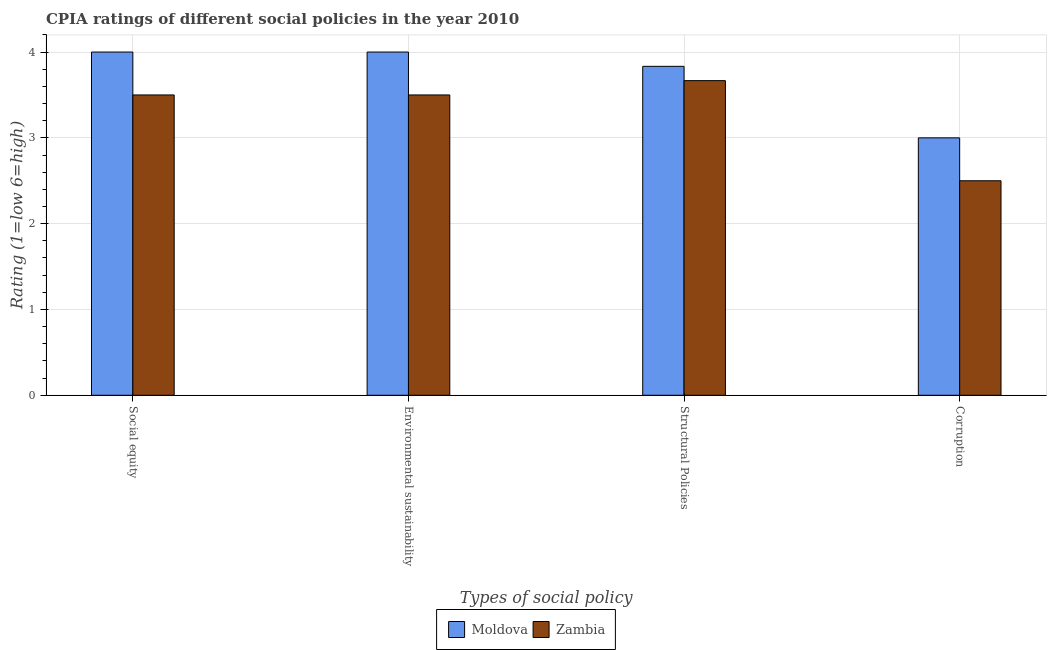How many different coloured bars are there?
Provide a succinct answer. 2. Are the number of bars per tick equal to the number of legend labels?
Give a very brief answer. Yes. Are the number of bars on each tick of the X-axis equal?
Your response must be concise. Yes. How many bars are there on the 1st tick from the right?
Make the answer very short. 2. What is the label of the 2nd group of bars from the left?
Offer a terse response. Environmental sustainability. What is the cpia rating of social equity in Moldova?
Your response must be concise. 4. Across all countries, what is the maximum cpia rating of structural policies?
Provide a succinct answer. 3.83. Across all countries, what is the minimum cpia rating of structural policies?
Offer a terse response. 3.67. In which country was the cpia rating of structural policies maximum?
Make the answer very short. Moldova. In which country was the cpia rating of social equity minimum?
Offer a terse response. Zambia. What is the difference between the cpia rating of structural policies in Zambia and the cpia rating of social equity in Moldova?
Keep it short and to the point. -0.33. What is the average cpia rating of corruption per country?
Offer a very short reply. 2.75. Is the cpia rating of environmental sustainability in Moldova less than that in Zambia?
Provide a short and direct response. No. Is the difference between the cpia rating of social equity in Zambia and Moldova greater than the difference between the cpia rating of corruption in Zambia and Moldova?
Make the answer very short. No. What is the difference between the highest and the second highest cpia rating of environmental sustainability?
Make the answer very short. 0.5. What is the difference between the highest and the lowest cpia rating of structural policies?
Provide a short and direct response. 0.17. Is the sum of the cpia rating of social equity in Moldova and Zambia greater than the maximum cpia rating of structural policies across all countries?
Your response must be concise. Yes. Is it the case that in every country, the sum of the cpia rating of structural policies and cpia rating of environmental sustainability is greater than the sum of cpia rating of social equity and cpia rating of corruption?
Offer a very short reply. Yes. What does the 2nd bar from the left in Social equity represents?
Make the answer very short. Zambia. What does the 1st bar from the right in Environmental sustainability represents?
Your answer should be compact. Zambia. Is it the case that in every country, the sum of the cpia rating of social equity and cpia rating of environmental sustainability is greater than the cpia rating of structural policies?
Your answer should be compact. Yes. How many bars are there?
Keep it short and to the point. 8. Are the values on the major ticks of Y-axis written in scientific E-notation?
Make the answer very short. No. Does the graph contain grids?
Offer a very short reply. Yes. How are the legend labels stacked?
Your response must be concise. Horizontal. What is the title of the graph?
Offer a terse response. CPIA ratings of different social policies in the year 2010. What is the label or title of the X-axis?
Your response must be concise. Types of social policy. What is the Rating (1=low 6=high) of Moldova in Social equity?
Your answer should be very brief. 4. What is the Rating (1=low 6=high) of Zambia in Environmental sustainability?
Offer a terse response. 3.5. What is the Rating (1=low 6=high) in Moldova in Structural Policies?
Your response must be concise. 3.83. What is the Rating (1=low 6=high) in Zambia in Structural Policies?
Ensure brevity in your answer.  3.67. Across all Types of social policy, what is the maximum Rating (1=low 6=high) of Moldova?
Provide a short and direct response. 4. Across all Types of social policy, what is the maximum Rating (1=low 6=high) in Zambia?
Make the answer very short. 3.67. Across all Types of social policy, what is the minimum Rating (1=low 6=high) in Zambia?
Provide a succinct answer. 2.5. What is the total Rating (1=low 6=high) in Moldova in the graph?
Offer a terse response. 14.83. What is the total Rating (1=low 6=high) in Zambia in the graph?
Keep it short and to the point. 13.17. What is the difference between the Rating (1=low 6=high) in Zambia in Social equity and that in Environmental sustainability?
Your answer should be very brief. 0. What is the difference between the Rating (1=low 6=high) in Moldova in Social equity and that in Structural Policies?
Keep it short and to the point. 0.17. What is the difference between the Rating (1=low 6=high) of Moldova in Social equity and that in Corruption?
Your answer should be compact. 1. What is the difference between the Rating (1=low 6=high) of Moldova in Environmental sustainability and that in Corruption?
Your response must be concise. 1. What is the difference between the Rating (1=low 6=high) in Zambia in Environmental sustainability and that in Corruption?
Offer a terse response. 1. What is the difference between the Rating (1=low 6=high) in Moldova in Structural Policies and that in Corruption?
Your answer should be compact. 0.83. What is the difference between the Rating (1=low 6=high) in Moldova in Social equity and the Rating (1=low 6=high) in Zambia in Environmental sustainability?
Provide a short and direct response. 0.5. What is the difference between the Rating (1=low 6=high) of Moldova in Social equity and the Rating (1=low 6=high) of Zambia in Structural Policies?
Offer a terse response. 0.33. What is the difference between the Rating (1=low 6=high) of Moldova in Social equity and the Rating (1=low 6=high) of Zambia in Corruption?
Offer a terse response. 1.5. What is the difference between the Rating (1=low 6=high) of Moldova in Environmental sustainability and the Rating (1=low 6=high) of Zambia in Structural Policies?
Make the answer very short. 0.33. What is the difference between the Rating (1=low 6=high) of Moldova in Structural Policies and the Rating (1=low 6=high) of Zambia in Corruption?
Make the answer very short. 1.33. What is the average Rating (1=low 6=high) in Moldova per Types of social policy?
Your response must be concise. 3.71. What is the average Rating (1=low 6=high) in Zambia per Types of social policy?
Provide a succinct answer. 3.29. What is the difference between the Rating (1=low 6=high) in Moldova and Rating (1=low 6=high) in Zambia in Social equity?
Offer a terse response. 0.5. What is the difference between the Rating (1=low 6=high) in Moldova and Rating (1=low 6=high) in Zambia in Environmental sustainability?
Make the answer very short. 0.5. What is the difference between the Rating (1=low 6=high) in Moldova and Rating (1=low 6=high) in Zambia in Corruption?
Offer a very short reply. 0.5. What is the ratio of the Rating (1=low 6=high) of Moldova in Social equity to that in Structural Policies?
Make the answer very short. 1.04. What is the ratio of the Rating (1=low 6=high) of Zambia in Social equity to that in Structural Policies?
Your response must be concise. 0.95. What is the ratio of the Rating (1=low 6=high) in Moldova in Social equity to that in Corruption?
Ensure brevity in your answer.  1.33. What is the ratio of the Rating (1=low 6=high) in Zambia in Social equity to that in Corruption?
Give a very brief answer. 1.4. What is the ratio of the Rating (1=low 6=high) of Moldova in Environmental sustainability to that in Structural Policies?
Keep it short and to the point. 1.04. What is the ratio of the Rating (1=low 6=high) of Zambia in Environmental sustainability to that in Structural Policies?
Offer a very short reply. 0.95. What is the ratio of the Rating (1=low 6=high) in Moldova in Structural Policies to that in Corruption?
Make the answer very short. 1.28. What is the ratio of the Rating (1=low 6=high) of Zambia in Structural Policies to that in Corruption?
Your answer should be compact. 1.47. 